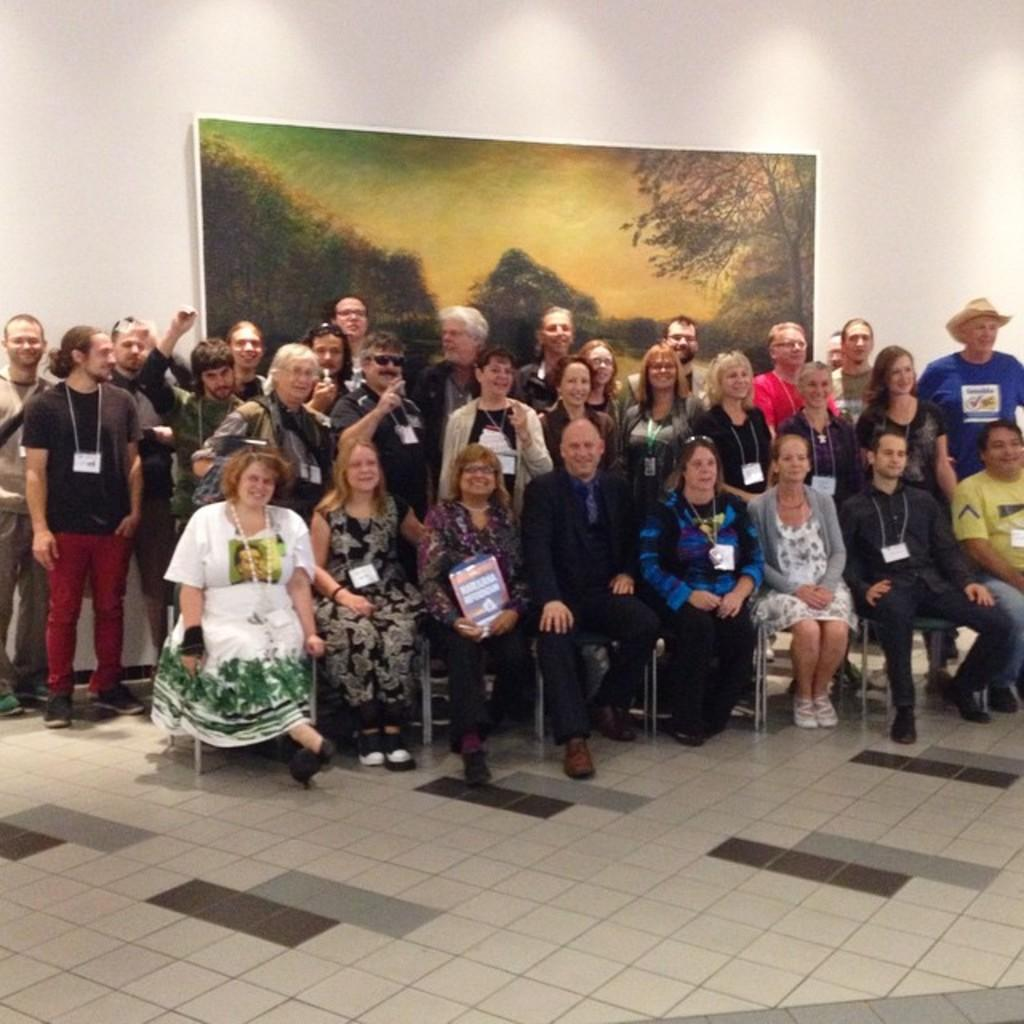What are the people in the image doing? There are people standing and seated in the image. What are some people holding in the image? Some people are holding ID cards in the image. Can you describe the appearance of one person in the image? There is a man wearing a hat in the image. What can be seen on the wall in the image? There is a photo frame on the wall in the image. What type of cart is being used to transport the hour in the image? There is no cart or hour present in the image. Can you tell me how many needles are visible in the image? There are no needles visible in the image. 